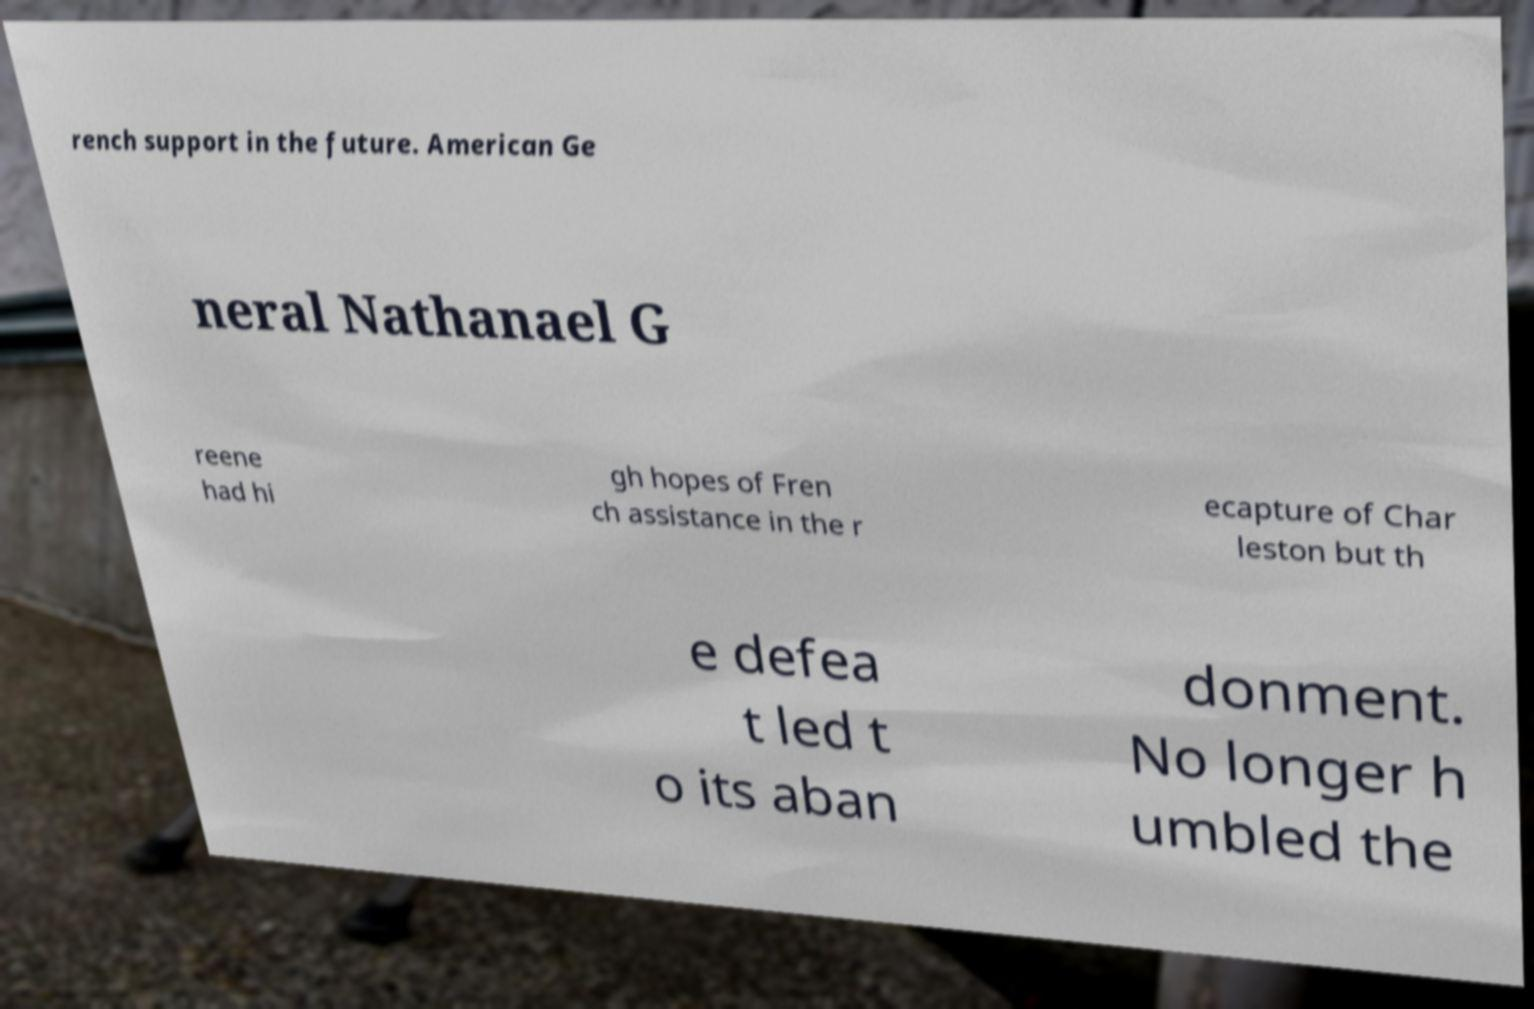Can you accurately transcribe the text from the provided image for me? rench support in the future. American Ge neral Nathanael G reene had hi gh hopes of Fren ch assistance in the r ecapture of Char leston but th e defea t led t o its aban donment. No longer h umbled the 